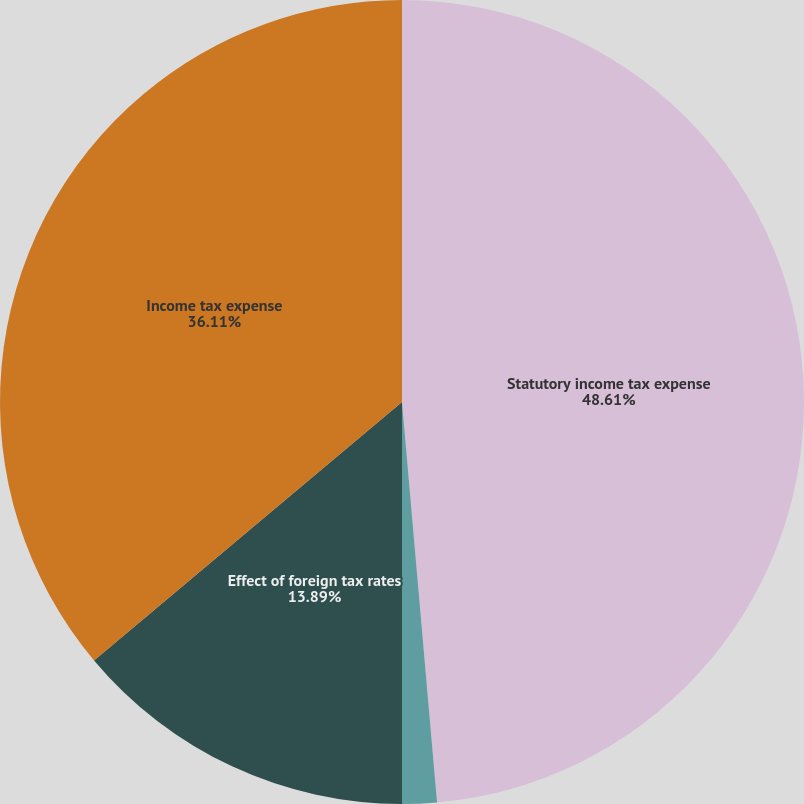<chart> <loc_0><loc_0><loc_500><loc_500><pie_chart><fcel>Statutory income tax expense<fcel>State and local taxes (net of<fcel>Effect of foreign tax rates<fcel>Income tax expense<nl><fcel>48.61%<fcel>1.39%<fcel>13.89%<fcel>36.11%<nl></chart> 